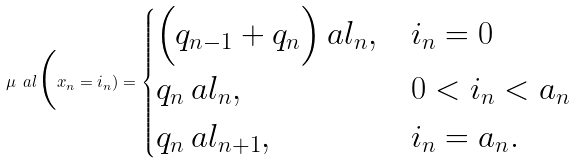Convert formula to latex. <formula><loc_0><loc_0><loc_500><loc_500>\mu _ { \ } a l \Big ( x _ { n } = i _ { n } ) = \begin{cases} \Big ( q _ { n - 1 } + q _ { n } \Big ) \ a l _ { n } , & i _ { n } = 0 \\ q _ { n } \ a l _ { n } , & 0 < i _ { n } < a _ { n } \\ q _ { n } \ a l _ { n + 1 } , & i _ { n } = a _ { n } . \end{cases}</formula> 